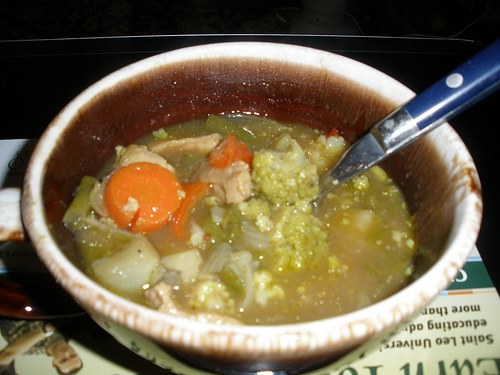In a futuristic world, what new ingredients or features might this soup have? In a futuristic world, this soup might include ingredients like algae or edible flowers for enhanced nutrition, or even synthetic meat that mimics the taste and texture of real meat but is made sustainably. The broth could be infused with nanobots that monitor and improve your health as you eat, ensuring you get the right balance of nutrients tailored to your body's needs. The bowl might also be self-heating, ensuring the soup remains at the perfect temperature throughout your meal. 